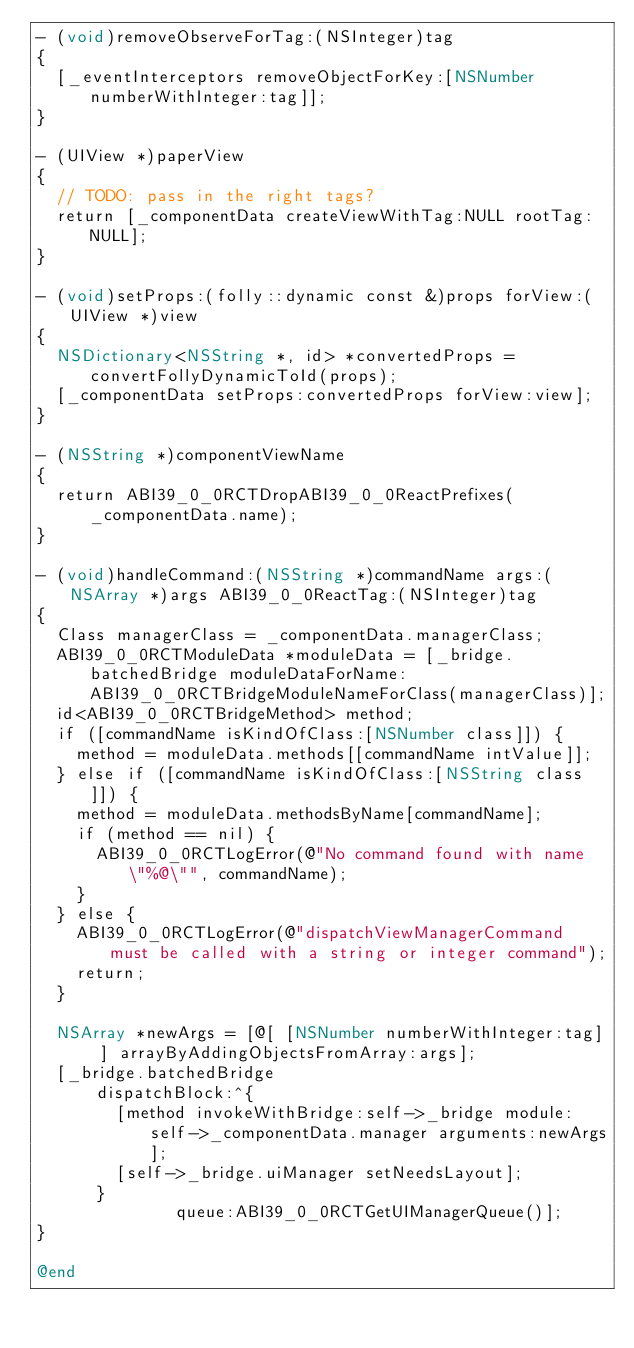Convert code to text. <code><loc_0><loc_0><loc_500><loc_500><_ObjectiveC_>- (void)removeObserveForTag:(NSInteger)tag
{
  [_eventInterceptors removeObjectForKey:[NSNumber numberWithInteger:tag]];
}

- (UIView *)paperView
{
  // TODO: pass in the right tags?
  return [_componentData createViewWithTag:NULL rootTag:NULL];
}

- (void)setProps:(folly::dynamic const &)props forView:(UIView *)view
{
  NSDictionary<NSString *, id> *convertedProps = convertFollyDynamicToId(props);
  [_componentData setProps:convertedProps forView:view];
}

- (NSString *)componentViewName
{
  return ABI39_0_0RCTDropABI39_0_0ReactPrefixes(_componentData.name);
}

- (void)handleCommand:(NSString *)commandName args:(NSArray *)args ABI39_0_0ReactTag:(NSInteger)tag
{
  Class managerClass = _componentData.managerClass;
  ABI39_0_0RCTModuleData *moduleData = [_bridge.batchedBridge moduleDataForName:ABI39_0_0RCTBridgeModuleNameForClass(managerClass)];
  id<ABI39_0_0RCTBridgeMethod> method;
  if ([commandName isKindOfClass:[NSNumber class]]) {
    method = moduleData.methods[[commandName intValue]];
  } else if ([commandName isKindOfClass:[NSString class]]) {
    method = moduleData.methodsByName[commandName];
    if (method == nil) {
      ABI39_0_0RCTLogError(@"No command found with name \"%@\"", commandName);
    }
  } else {
    ABI39_0_0RCTLogError(@"dispatchViewManagerCommand must be called with a string or integer command");
    return;
  }

  NSArray *newArgs = [@[ [NSNumber numberWithInteger:tag] ] arrayByAddingObjectsFromArray:args];
  [_bridge.batchedBridge
      dispatchBlock:^{
        [method invokeWithBridge:self->_bridge module:self->_componentData.manager arguments:newArgs];
        [self->_bridge.uiManager setNeedsLayout];
      }
              queue:ABI39_0_0RCTGetUIManagerQueue()];
}

@end
</code> 